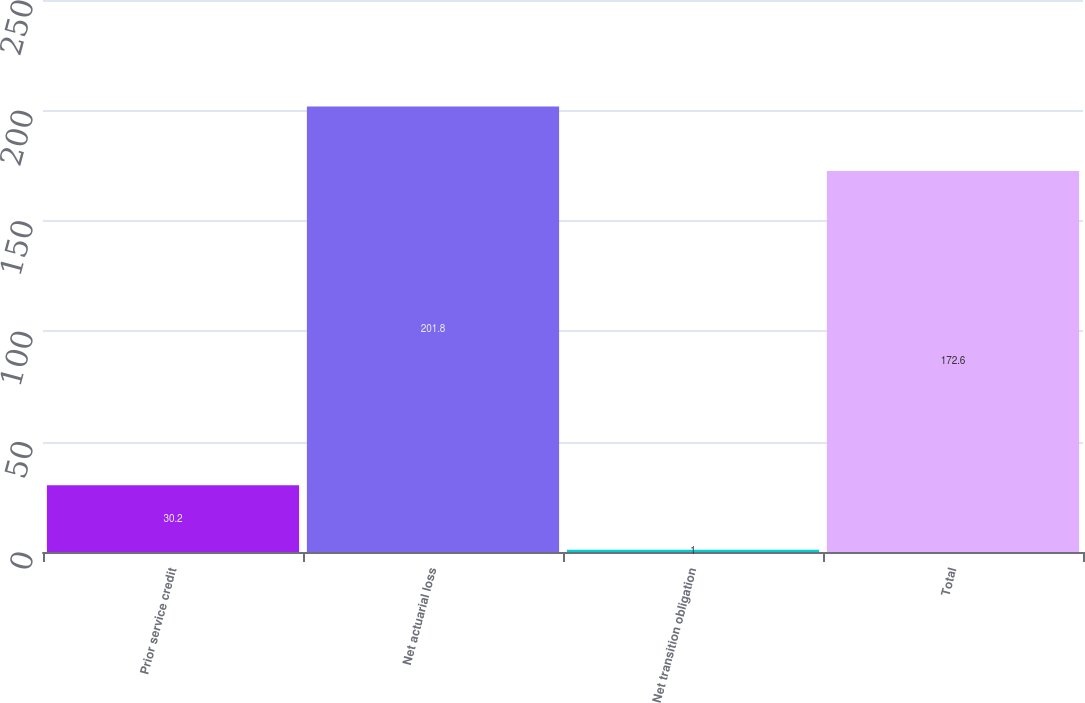Convert chart. <chart><loc_0><loc_0><loc_500><loc_500><bar_chart><fcel>Prior service credit<fcel>Net actuarial loss<fcel>Net transition obligation<fcel>Total<nl><fcel>30.2<fcel>201.8<fcel>1<fcel>172.6<nl></chart> 